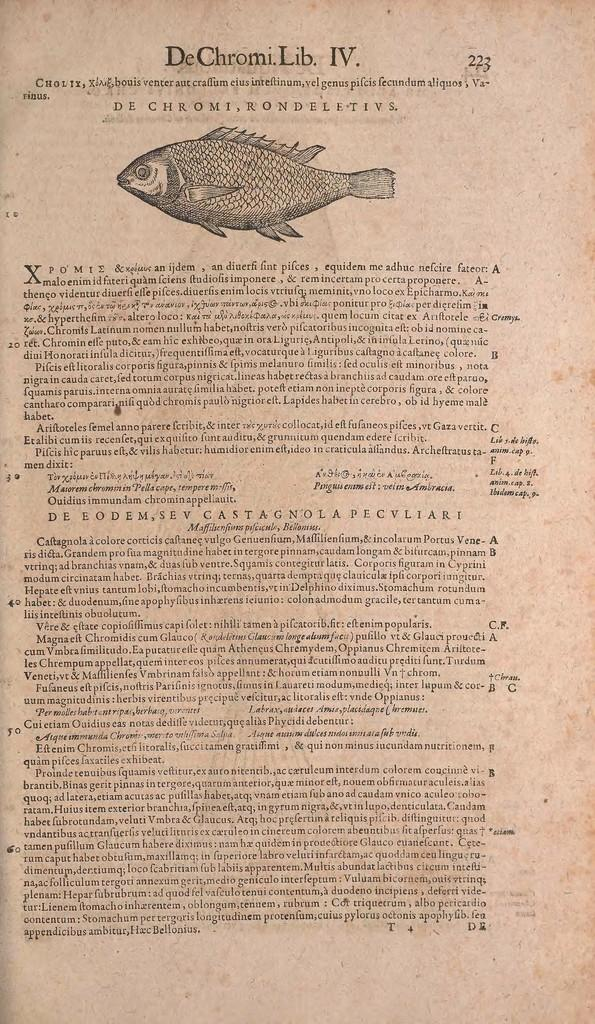What is the main subject of the image? The main subject of the image is an article. Is there any artwork or illustration in the image? Yes, there is a fish sketch at the top of the image. What type of gold jewelry is visible in the image? There is no gold jewelry present in the image. How many things are mentioned in the article in the image? The provided facts do not give information about the content of the article, so we cannot determine how many things are mentioned in it. 